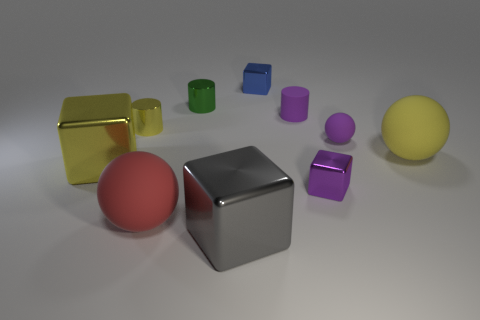Is the size of the blue block the same as the metallic cylinder on the right side of the red sphere?
Provide a succinct answer. Yes. Are there fewer yellow blocks right of the large red rubber ball than yellow cubes?
Make the answer very short. Yes. There is a green object that is the same shape as the small yellow object; what material is it?
Your answer should be compact. Metal. There is a rubber thing that is to the right of the large gray metal block and in front of the purple ball; what is its shape?
Keep it short and to the point. Sphere. The green thing that is the same material as the blue cube is what shape?
Provide a succinct answer. Cylinder. What is the material of the purple thing that is behind the small yellow cylinder?
Provide a succinct answer. Rubber. Does the green thing that is behind the large gray metallic object have the same size as the purple matte object on the left side of the purple shiny block?
Your answer should be very brief. Yes. There is a large metal thing left of the yellow metal cylinder; is it the same shape as the tiny purple metallic object?
Keep it short and to the point. Yes. What material is the yellow cylinder?
Make the answer very short. Metal. The yellow object that is the same size as the yellow block is what shape?
Offer a terse response. Sphere. 